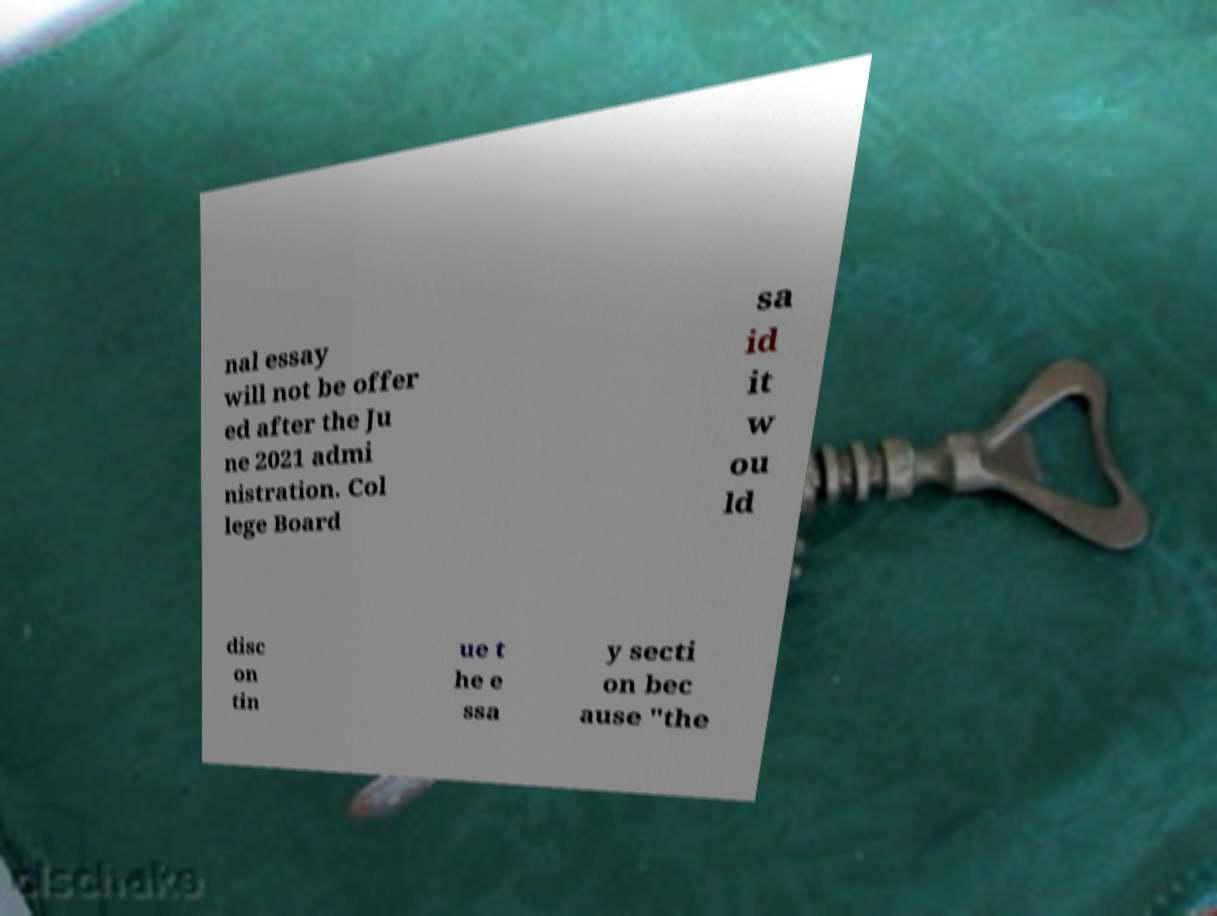Can you accurately transcribe the text from the provided image for me? nal essay will not be offer ed after the Ju ne 2021 admi nistration. Col lege Board sa id it w ou ld disc on tin ue t he e ssa y secti on bec ause "the 